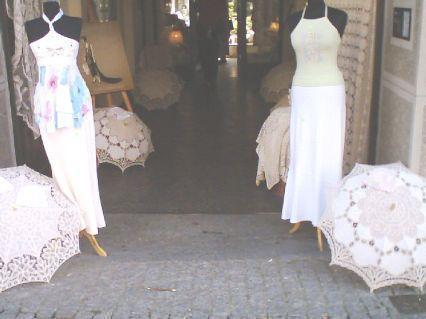How many dresses are sat around the entryway to the hall?
Make your selection and explain in format: 'Answer: answer
Rationale: rationale.'
Options: Four, three, five, two. Answer: two.
Rationale: There are two dresses.  one dress is on each side of the hall and they are nestled between parasols. 